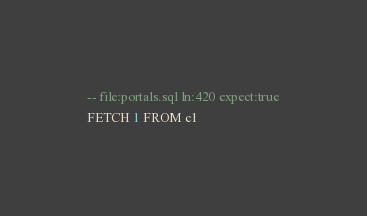Convert code to text. <code><loc_0><loc_0><loc_500><loc_500><_SQL_>-- file:portals.sql ln:420 expect:true
FETCH 1 FROM c1
</code> 